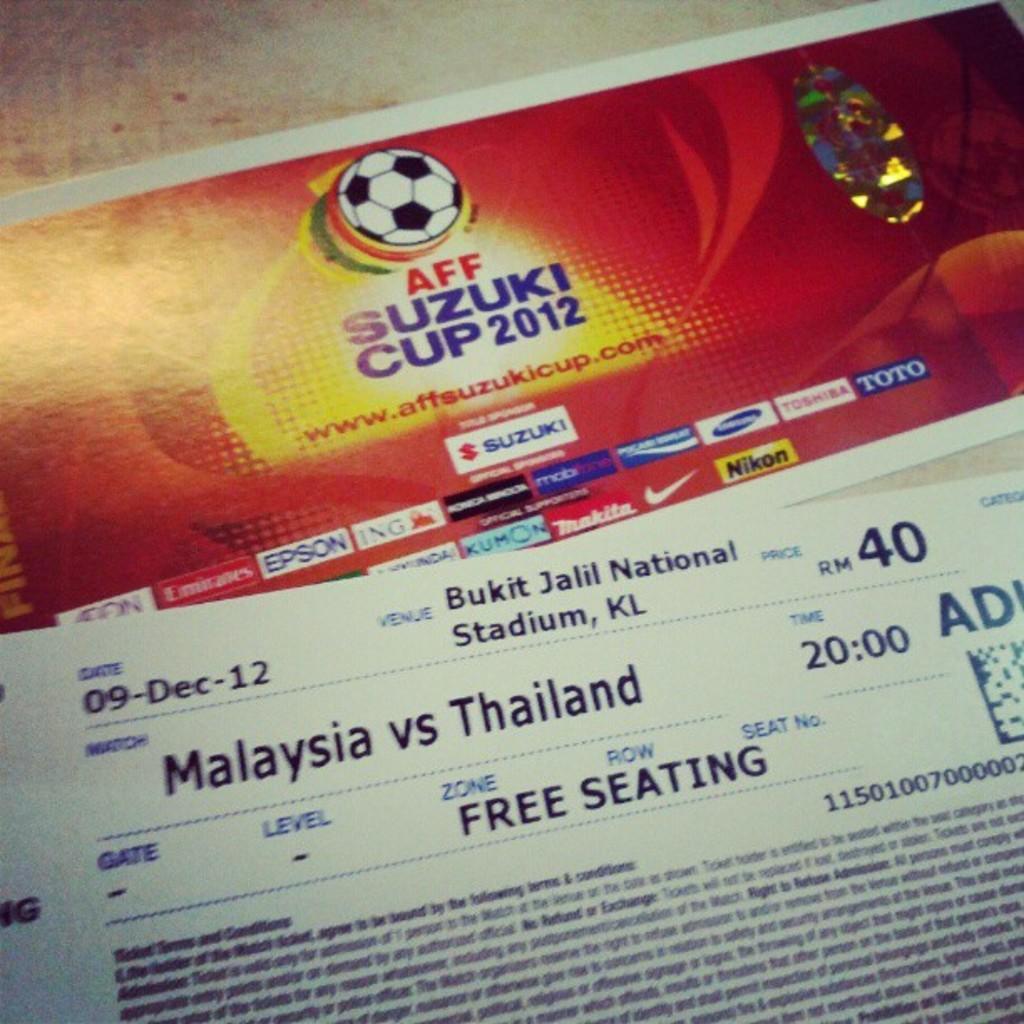Please provide a concise description of this image. In this image we can see tickets placed on the table. 